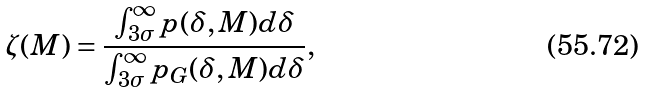Convert formula to latex. <formula><loc_0><loc_0><loc_500><loc_500>\zeta ( M ) = \frac { \int _ { 3 \sigma } ^ { \infty } p ( \delta , M ) d \delta } { \int _ { 3 \sigma } ^ { \infty } p _ { G } ( \delta , M ) d \delta } ,</formula> 